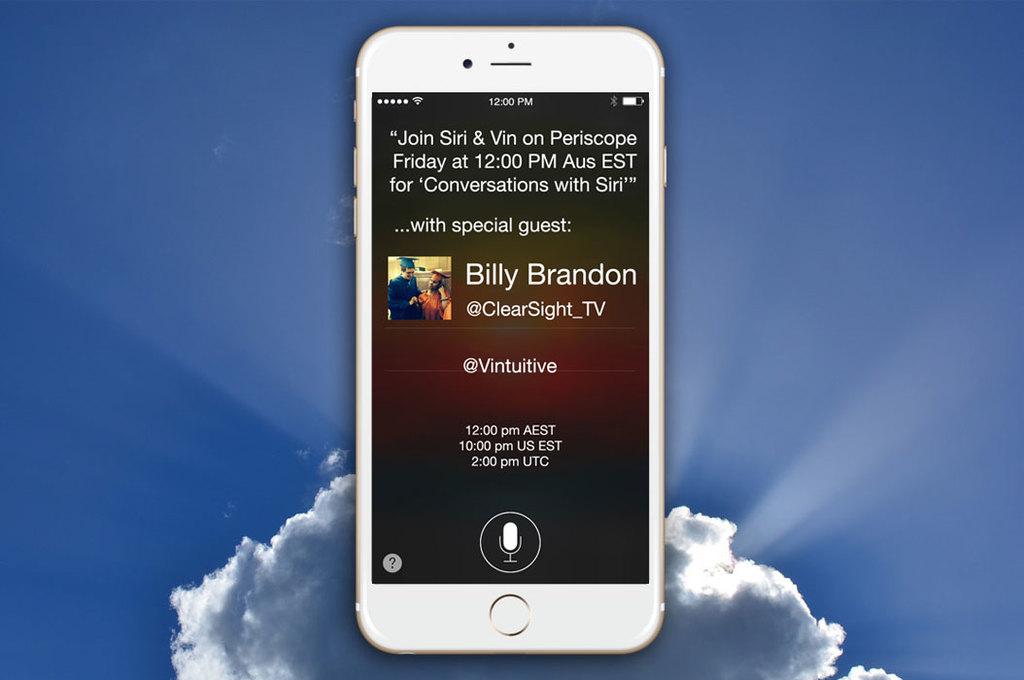What name is in the middle of the phone?
Provide a short and direct response. Billy brandon. What time is the event?
Keep it short and to the point. 12:00 pm. 